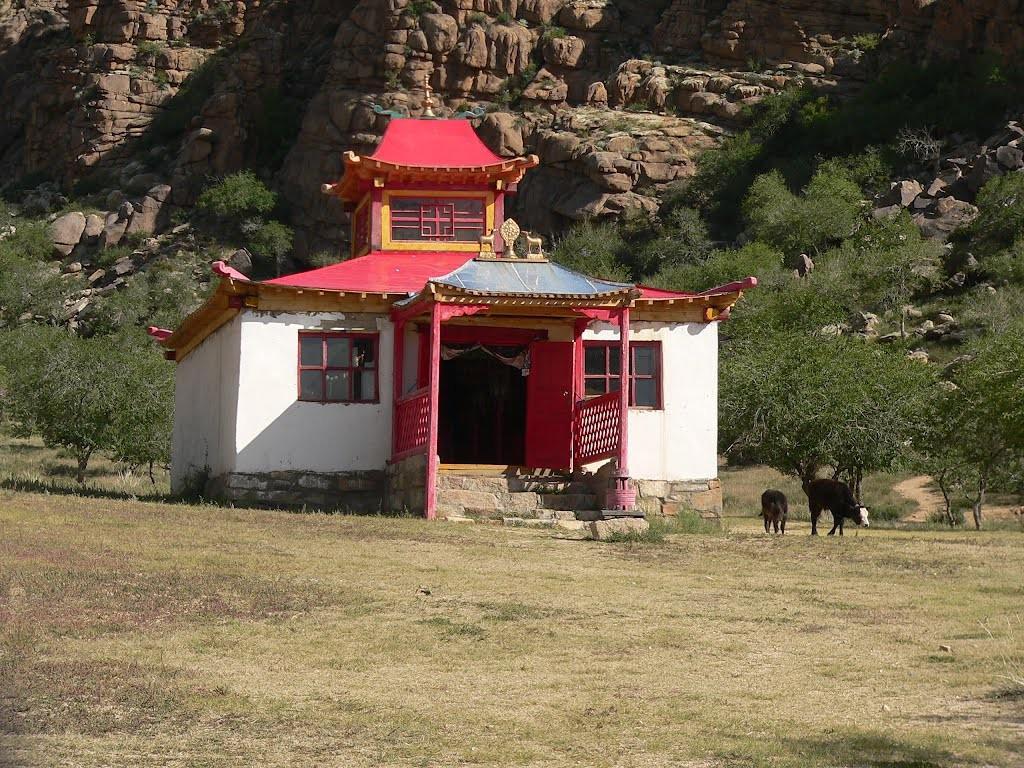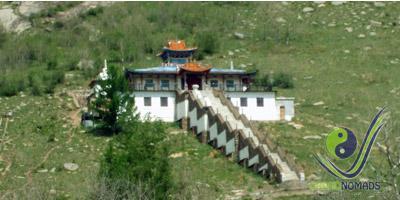The first image is the image on the left, the second image is the image on the right. For the images shown, is this caption "An image shows a structure with a yellow trimmed roof and a bulb-like yellow topper." true? Answer yes or no. No. 